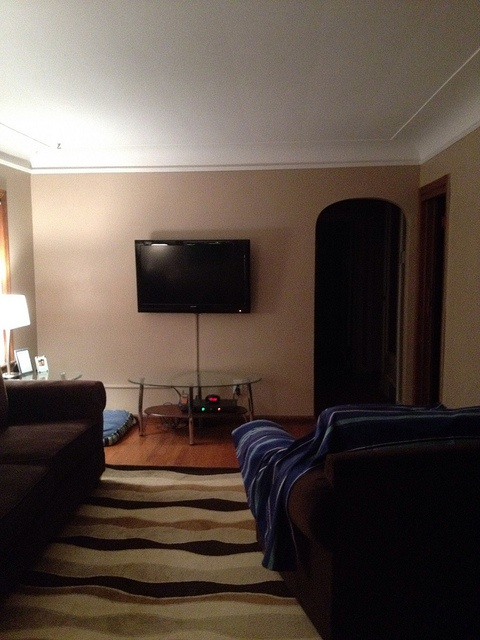Describe the objects in this image and their specific colors. I can see couch in lightgray, black, and gray tones, couch in lightgray, black, and gray tones, and tv in lightgray, black, and gray tones in this image. 